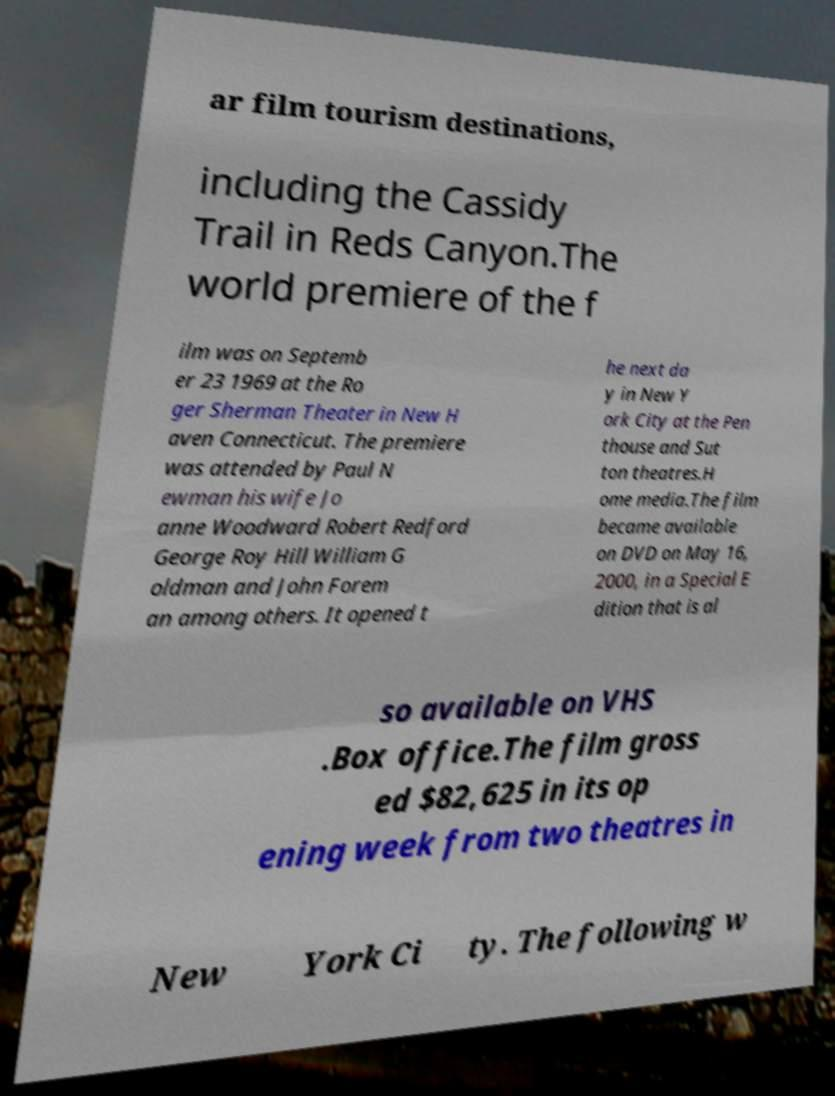Could you assist in decoding the text presented in this image and type it out clearly? ar film tourism destinations, including the Cassidy Trail in Reds Canyon.The world premiere of the f ilm was on Septemb er 23 1969 at the Ro ger Sherman Theater in New H aven Connecticut. The premiere was attended by Paul N ewman his wife Jo anne Woodward Robert Redford George Roy Hill William G oldman and John Forem an among others. It opened t he next da y in New Y ork City at the Pen thouse and Sut ton theatres.H ome media.The film became available on DVD on May 16, 2000, in a Special E dition that is al so available on VHS .Box office.The film gross ed $82,625 in its op ening week from two theatres in New York Ci ty. The following w 